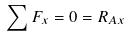Convert formula to latex. <formula><loc_0><loc_0><loc_500><loc_500>\sum F _ { x } = 0 = R _ { A x }</formula> 